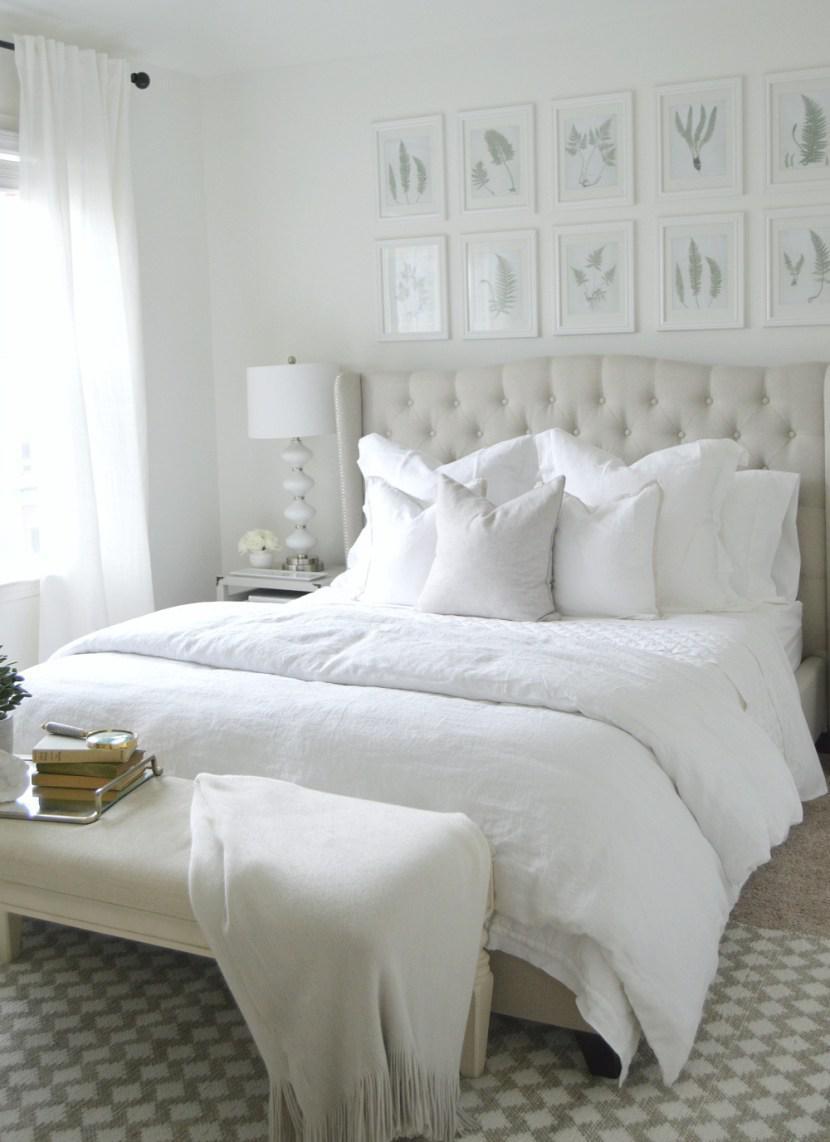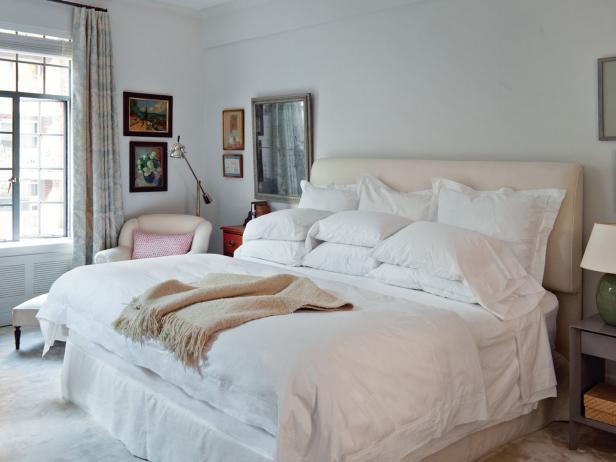The first image is the image on the left, the second image is the image on the right. Considering the images on both sides, is "An image shows pillows in front of a non-tufted headboard." valid? Answer yes or no. Yes. The first image is the image on the left, the second image is the image on the right. For the images shown, is this caption "A window near the bed is letting in natural light." true? Answer yes or no. Yes. 